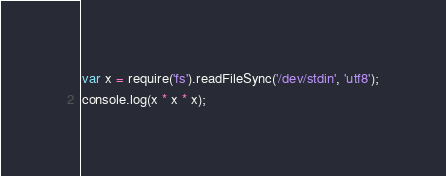<code> <loc_0><loc_0><loc_500><loc_500><_JavaScript_>var x = require('fs').readFileSync('/dev/stdin', 'utf8');
console.log(x * x * x);</code> 